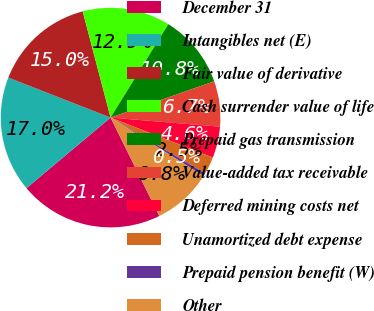Convert chart. <chart><loc_0><loc_0><loc_500><loc_500><pie_chart><fcel>December 31<fcel>Intangibles net (E)<fcel>Fair value of derivative<fcel>Cash surrender value of life<fcel>Prepaid gas transmission<fcel>Value-added tax receivable<fcel>Deferred mining costs net<fcel>Unamortized debt expense<fcel>Prepaid pension benefit (W)<fcel>Other<nl><fcel>21.2%<fcel>17.05%<fcel>14.98%<fcel>12.9%<fcel>10.83%<fcel>6.68%<fcel>4.61%<fcel>2.54%<fcel>0.46%<fcel>8.76%<nl></chart> 